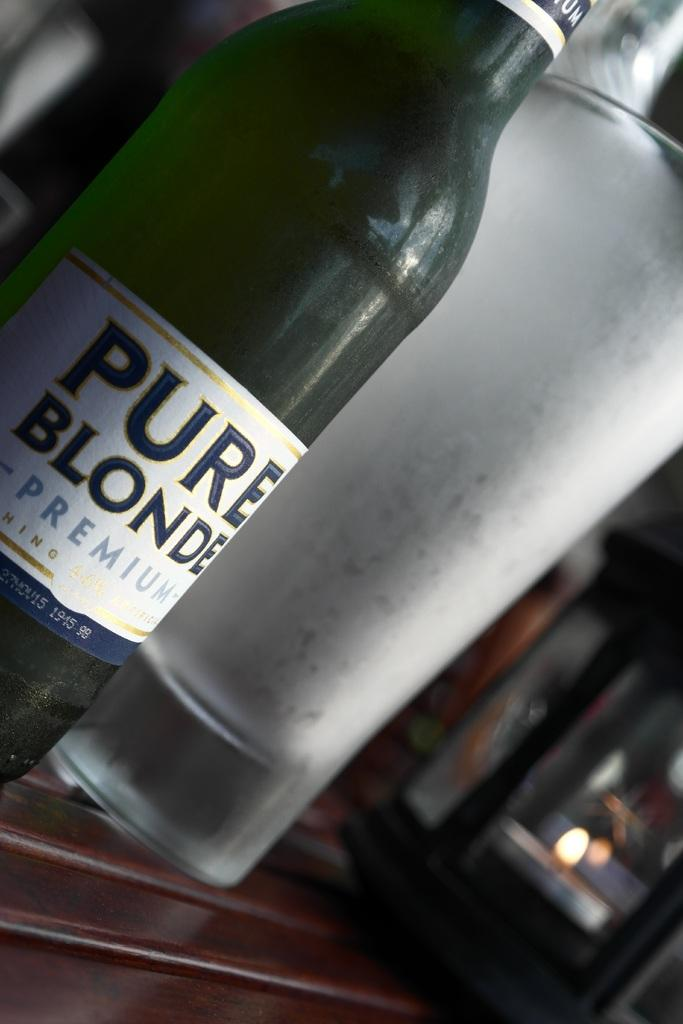<image>
Describe the image concisely. Wine bottle with a label which says PURE BLONDE. 